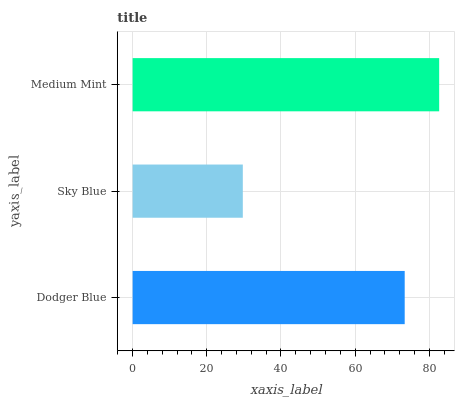Is Sky Blue the minimum?
Answer yes or no. Yes. Is Medium Mint the maximum?
Answer yes or no. Yes. Is Medium Mint the minimum?
Answer yes or no. No. Is Sky Blue the maximum?
Answer yes or no. No. Is Medium Mint greater than Sky Blue?
Answer yes or no. Yes. Is Sky Blue less than Medium Mint?
Answer yes or no. Yes. Is Sky Blue greater than Medium Mint?
Answer yes or no. No. Is Medium Mint less than Sky Blue?
Answer yes or no. No. Is Dodger Blue the high median?
Answer yes or no. Yes. Is Dodger Blue the low median?
Answer yes or no. Yes. Is Sky Blue the high median?
Answer yes or no. No. Is Medium Mint the low median?
Answer yes or no. No. 